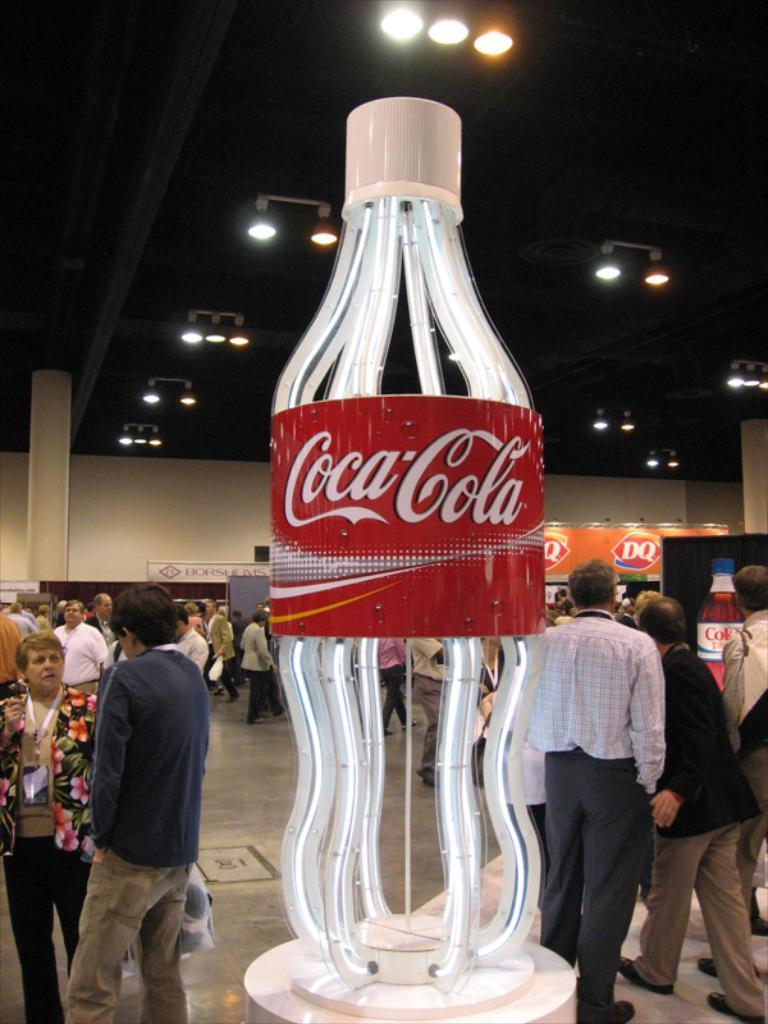What are the people in the image doing? The people in the image are on a path. What object can be seen in the image besides the people? There is a board in the image. What can be seen in the background of the image? There is a wall and lights on the ceiling in the background of the image. What type of treatment is being administered to the bears in the image? There are no bears present in the image, so no treatment is being administered. What color is the dress worn by the person in the image? There is no person wearing a dress in the image. 